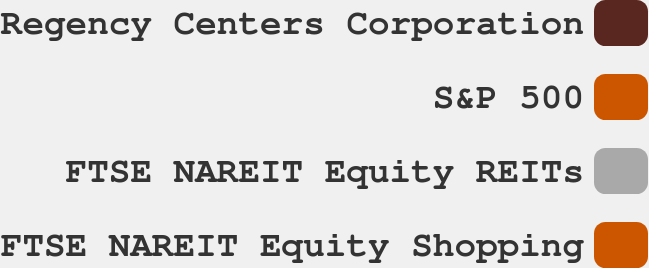Convert chart to OTSL. <chart><loc_0><loc_0><loc_500><loc_500><pie_chart><fcel>Regency Centers Corporation<fcel>S&P 500<fcel>FTSE NAREIT Equity REITs<fcel>FTSE NAREIT Equity Shopping<nl><fcel>26.13%<fcel>26.89%<fcel>23.67%<fcel>23.31%<nl></chart> 